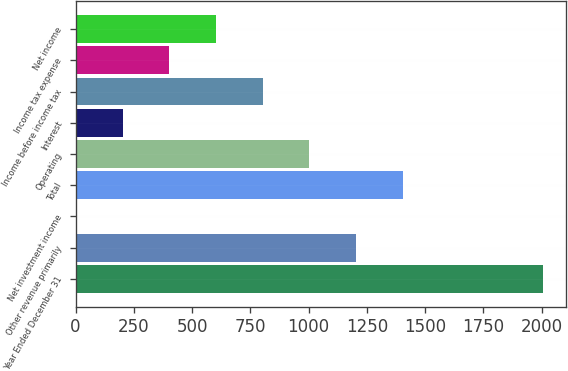Convert chart to OTSL. <chart><loc_0><loc_0><loc_500><loc_500><bar_chart><fcel>Year Ended December 31<fcel>Other revenue primarily<fcel>Net investment income<fcel>Total<fcel>Operating<fcel>Interest<fcel>Income before income tax<fcel>Income tax expense<fcel>Net income<nl><fcel>2006<fcel>1204<fcel>1<fcel>1404.5<fcel>1003.5<fcel>201.5<fcel>803<fcel>402<fcel>602.5<nl></chart> 